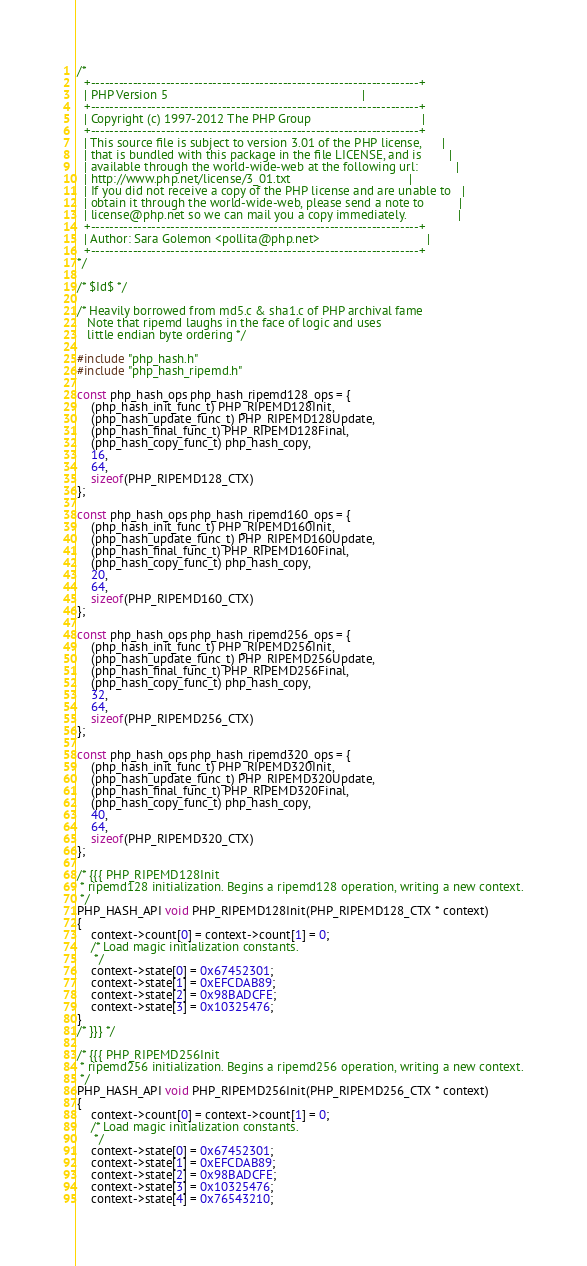<code> <loc_0><loc_0><loc_500><loc_500><_C_>/*
  +----------------------------------------------------------------------+
  | PHP Version 5                                                        |
  +----------------------------------------------------------------------+
  | Copyright (c) 1997-2012 The PHP Group                                |
  +----------------------------------------------------------------------+
  | This source file is subject to version 3.01 of the PHP license,      |
  | that is bundled with this package in the file LICENSE, and is        |
  | available through the world-wide-web at the following url:           |
  | http://www.php.net/license/3_01.txt                                  |
  | If you did not receive a copy of the PHP license and are unable to   |
  | obtain it through the world-wide-web, please send a note to          |
  | license@php.net so we can mail you a copy immediately.               |
  +----------------------------------------------------------------------+
  | Author: Sara Golemon <pollita@php.net>                               |
  +----------------------------------------------------------------------+
*/

/* $Id$ */

/* Heavily borrowed from md5.c & sha1.c of PHP archival fame
   Note that ripemd laughs in the face of logic and uses
   little endian byte ordering */

#include "php_hash.h"
#include "php_hash_ripemd.h"

const php_hash_ops php_hash_ripemd128_ops = {
	(php_hash_init_func_t) PHP_RIPEMD128Init,
	(php_hash_update_func_t) PHP_RIPEMD128Update,
	(php_hash_final_func_t) PHP_RIPEMD128Final,
	(php_hash_copy_func_t) php_hash_copy,
	16,
	64,
	sizeof(PHP_RIPEMD128_CTX)
};

const php_hash_ops php_hash_ripemd160_ops = {
	(php_hash_init_func_t) PHP_RIPEMD160Init,
	(php_hash_update_func_t) PHP_RIPEMD160Update,
	(php_hash_final_func_t) PHP_RIPEMD160Final,
	(php_hash_copy_func_t) php_hash_copy,
	20,
	64,
	sizeof(PHP_RIPEMD160_CTX)
};

const php_hash_ops php_hash_ripemd256_ops = {
	(php_hash_init_func_t) PHP_RIPEMD256Init,
	(php_hash_update_func_t) PHP_RIPEMD256Update,
	(php_hash_final_func_t) PHP_RIPEMD256Final,
	(php_hash_copy_func_t) php_hash_copy,
	32,
	64,
	sizeof(PHP_RIPEMD256_CTX)
};

const php_hash_ops php_hash_ripemd320_ops = {
	(php_hash_init_func_t) PHP_RIPEMD320Init,
	(php_hash_update_func_t) PHP_RIPEMD320Update,
	(php_hash_final_func_t) PHP_RIPEMD320Final,
	(php_hash_copy_func_t) php_hash_copy,
	40,
	64,
	sizeof(PHP_RIPEMD320_CTX)
};

/* {{{ PHP_RIPEMD128Init
 * ripemd128 initialization. Begins a ripemd128 operation, writing a new context.
 */
PHP_HASH_API void PHP_RIPEMD128Init(PHP_RIPEMD128_CTX * context)
{
	context->count[0] = context->count[1] = 0;
	/* Load magic initialization constants.
	 */
	context->state[0] = 0x67452301;
	context->state[1] = 0xEFCDAB89;
	context->state[2] = 0x98BADCFE;
	context->state[3] = 0x10325476; 
}
/* }}} */

/* {{{ PHP_RIPEMD256Init
 * ripemd256 initialization. Begins a ripemd256 operation, writing a new context.
 */
PHP_HASH_API void PHP_RIPEMD256Init(PHP_RIPEMD256_CTX * context)
{
	context->count[0] = context->count[1] = 0;
	/* Load magic initialization constants.
	 */
	context->state[0] = 0x67452301;
	context->state[1] = 0xEFCDAB89;
	context->state[2] = 0x98BADCFE;
	context->state[3] = 0x10325476; 
	context->state[4] = 0x76543210;</code> 